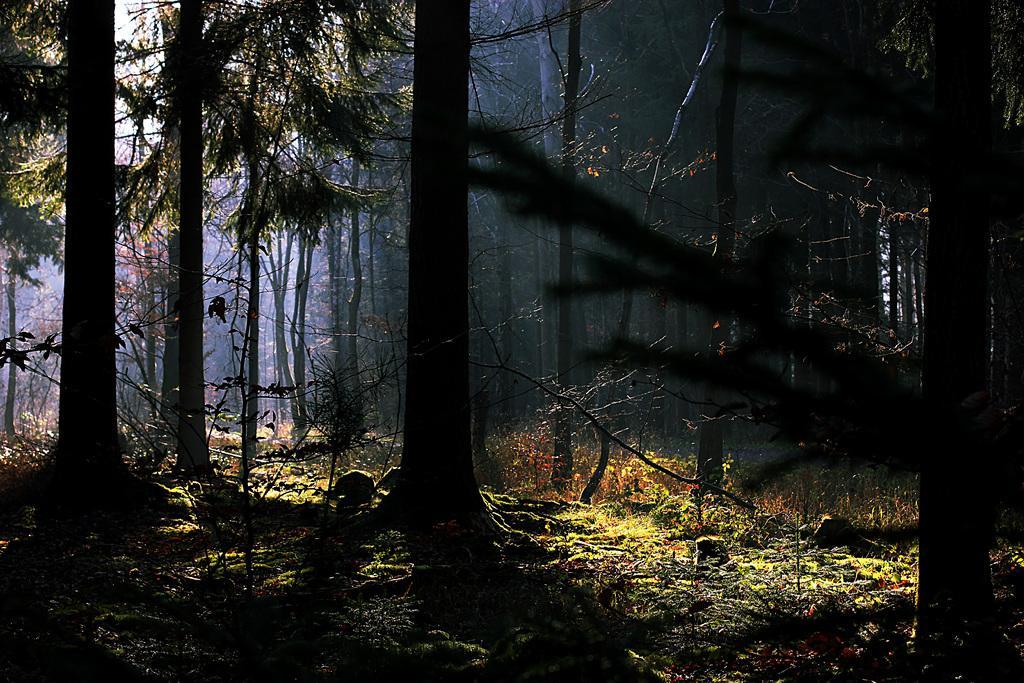Describe this image in one or two sentences. This is looking like a forest. In this image, I can see many trees on the ground and also I can see the grass and some plants. 